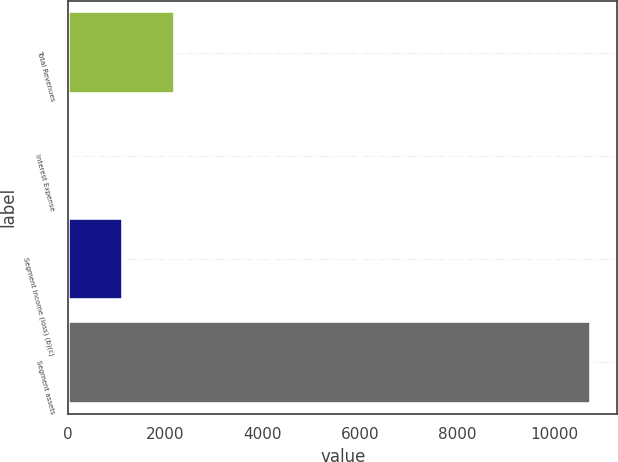Convert chart to OTSL. <chart><loc_0><loc_0><loc_500><loc_500><bar_chart><fcel>Total Revenues<fcel>Interest Expense<fcel>Segment income (loss) (b)(c)<fcel>Segment assets<nl><fcel>2188.8<fcel>46<fcel>1117.4<fcel>10760<nl></chart> 